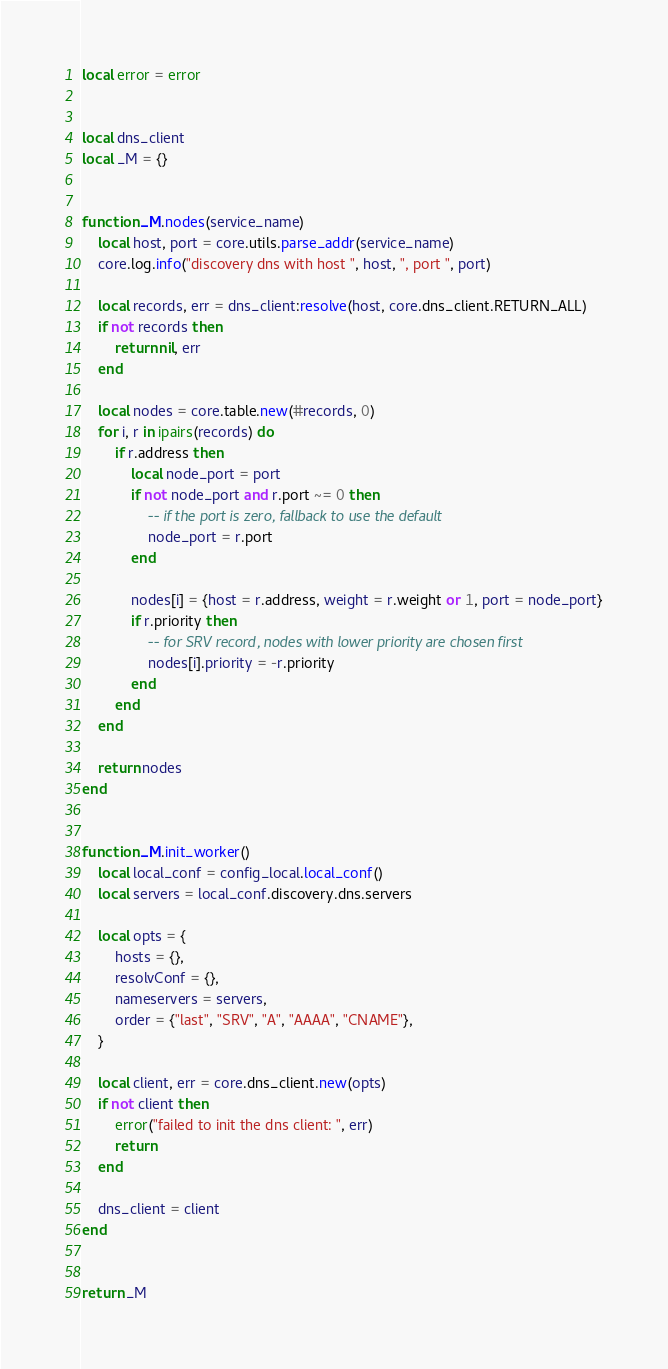Convert code to text. <code><loc_0><loc_0><loc_500><loc_500><_Lua_>local error = error


local dns_client
local _M = {}


function _M.nodes(service_name)
    local host, port = core.utils.parse_addr(service_name)
    core.log.info("discovery dns with host ", host, ", port ", port)

    local records, err = dns_client:resolve(host, core.dns_client.RETURN_ALL)
    if not records then
        return nil, err
    end

    local nodes = core.table.new(#records, 0)
    for i, r in ipairs(records) do
        if r.address then
            local node_port = port
            if not node_port and r.port ~= 0 then
                -- if the port is zero, fallback to use the default
                node_port = r.port
            end

            nodes[i] = {host = r.address, weight = r.weight or 1, port = node_port}
            if r.priority then
                -- for SRV record, nodes with lower priority are chosen first
                nodes[i].priority = -r.priority
            end
        end
    end

    return nodes
end


function _M.init_worker()
    local local_conf = config_local.local_conf()
    local servers = local_conf.discovery.dns.servers

    local opts = {
        hosts = {},
        resolvConf = {},
        nameservers = servers,
        order = {"last", "SRV", "A", "AAAA", "CNAME"},
    }

    local client, err = core.dns_client.new(opts)
    if not client then
        error("failed to init the dns client: ", err)
        return
    end

    dns_client = client
end


return _M
</code> 